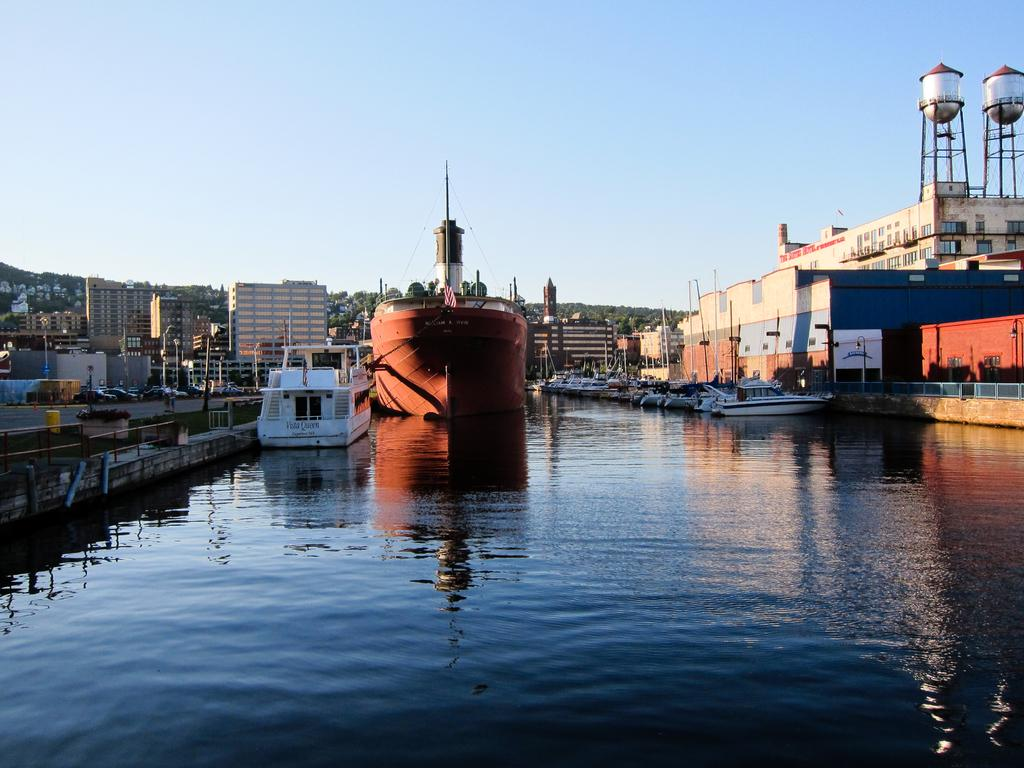What is the main subject of the image? The main subject of the image is a ship. What other watercraft can be seen in the image? There are boats in the image. Where are the boats located? The boats are on water. What type of structures are visible in the image? There are buildings in the image. What are the poles used for in the image? The purpose of the poles is not specified in the image. What type of vegetation is present in the image? There is grass in the image. What type of vehicles can be seen in the image? There are vehicles on the road in the image. What type of military equipment is present in the image? There are tanks in the image. What other objects can be seen in the image? There are other objects in the image, but their specific details are not mentioned. What is visible in the background of the image? The sky is visible in the background of the image. How many tickets are needed to ride the idea in the image? There is no mention of tickets or an idea in the image. The image features a ship, boats, water, buildings, poles, grass, vehicles, tanks, and other objects, but no tickets or ideas are present. 